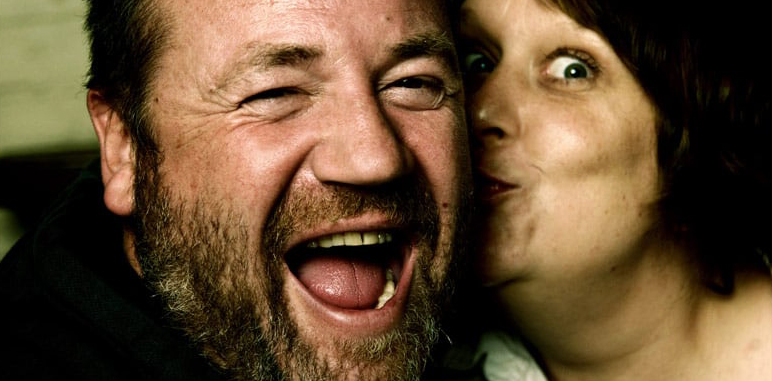Can you describe the emotions visible on the man's face? The man's face clearly shows a burst of laughter, reflecting sheer joy and merriment. His eyes are lightly closed, and his wide-open mouth indicates a deep, hearty laugh, suggesting he is in a moment of genuine happiness and amusement. 